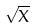<formula> <loc_0><loc_0><loc_500><loc_500>\sqrt { X }</formula> 